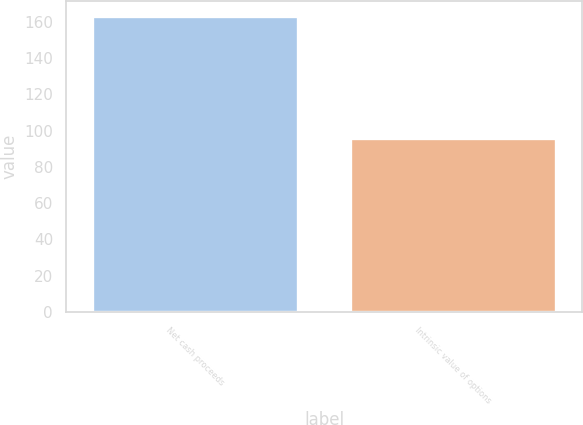Convert chart to OTSL. <chart><loc_0><loc_0><loc_500><loc_500><bar_chart><fcel>Net cash proceeds<fcel>Intrinsic value of options<nl><fcel>163.2<fcel>95.7<nl></chart> 